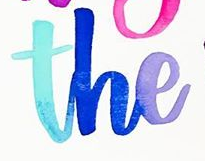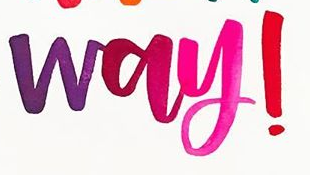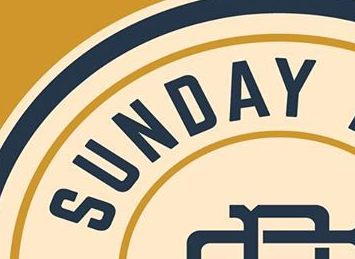Identify the words shown in these images in order, separated by a semicolon. the; way!; SUNDAY 